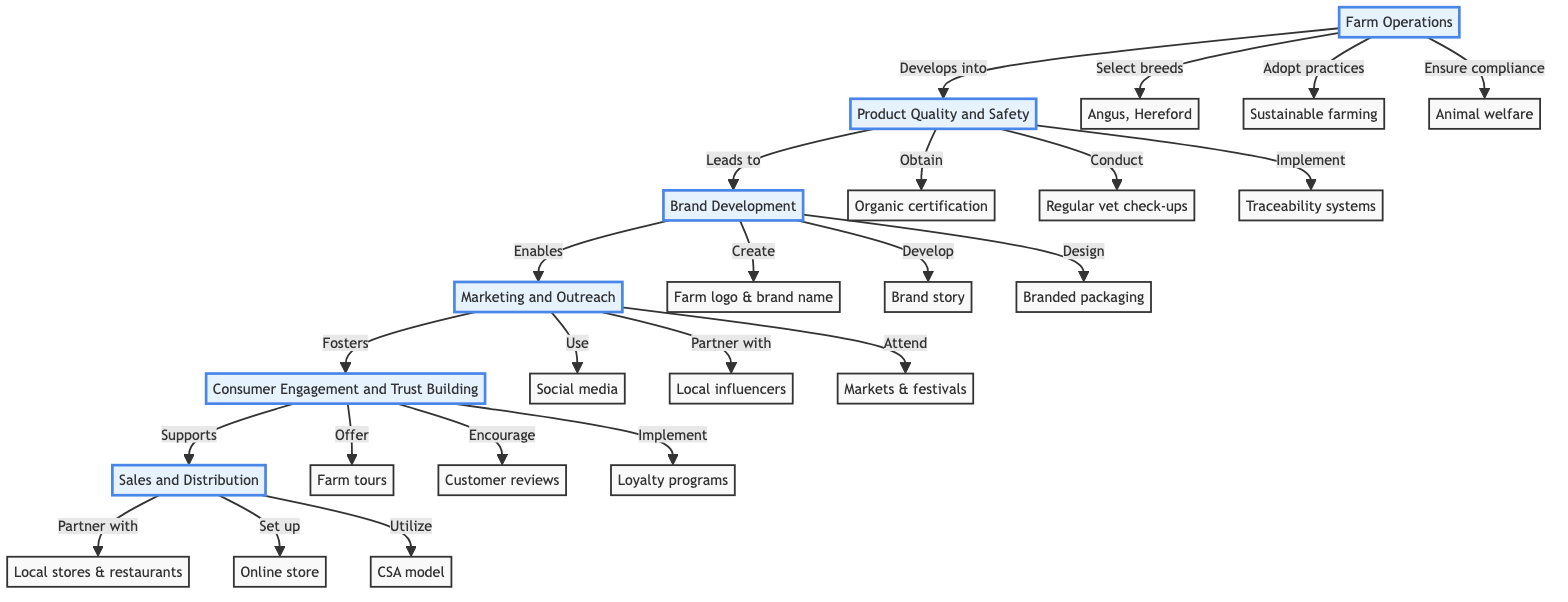What is the first stage in building a brand around grass-fed cattle? The diagram indicates that the first stage is "Farm Operations," as it is at the bottom of the flowchart and serves as the foundation for subsequent stages.
Answer: Farm Operations How many total stages are in the diagram? By counting the distinct stages listed from bottom to top, there are six stages present in the diagram.
Answer: 6 What follows "Brand Development" in the flowchart? Following "Brand Development," the next stage as represented in the diagram is "Marketing and Outreach."
Answer: Marketing and Outreach Which stage leads to consumer trust building? The "Marketing and Outreach" stage directly leads to "Consumer Engagement and Trust Building," showing the connection between marketing efforts and customer trust.
Answer: Marketing and Outreach What certification is obtained in the "Product Quality and Safety" stage? The diagram specifies that the certification obtained is "Organic certification," highlighting a key component of product quality in this stage.
Answer: Organic certification Which farming practices are adopted in the "Farm Operations" stage? According to the diagram, two key practices that are adopted include "Sustainable farming" and "Animal welfare." Both are crucial to the operation's foundation.
Answer: Sustainable farming What is the end stage of the flowchart? The final stage, which is at the top of the flowchart, is "Sales and Distribution," indicating the culmination of all previous stages into selling the products.
Answer: Sales and Distribution Which element encourages customer reviews in the flowchart? "Consumer Engagement and Trust Building" encourages customer reviews, making it a vital part of connecting with consumers and building trust.
Answer: Customer reviews What do farm tours offer in the engagement stage? The diagram states that farm tours offer "transparency," which is essential for enabling trust between the farm and its customers.
Answer: Transparency 